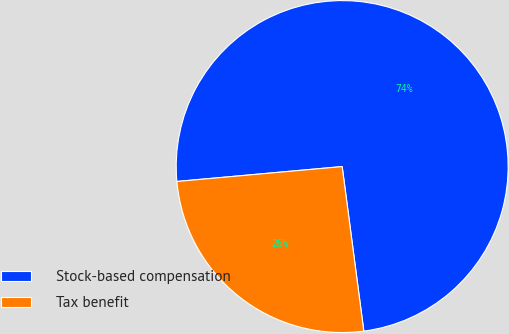Convert chart. <chart><loc_0><loc_0><loc_500><loc_500><pie_chart><fcel>Stock-based compensation<fcel>Tax benefit<nl><fcel>74.35%<fcel>25.65%<nl></chart> 